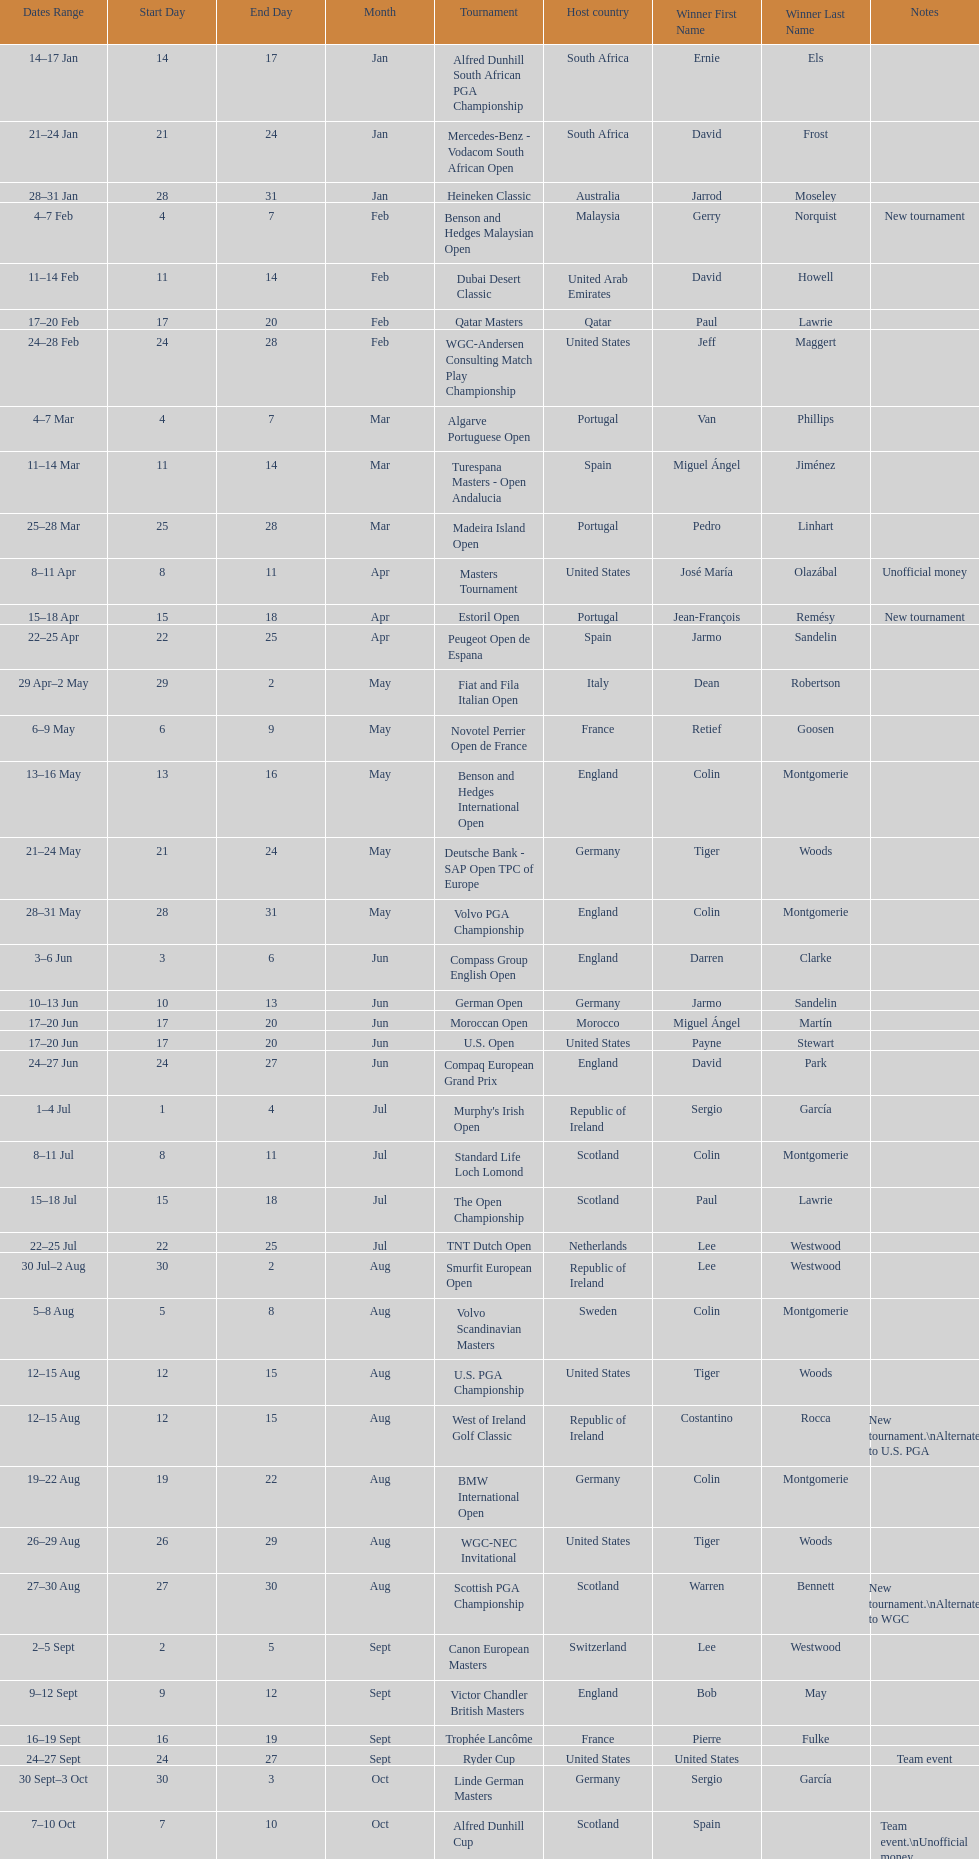Which winner won more tournaments, jeff maggert or tiger woods? Tiger Woods. 